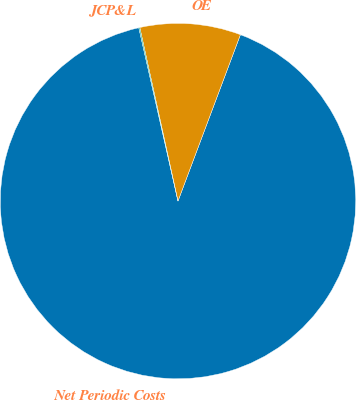<chart> <loc_0><loc_0><loc_500><loc_500><pie_chart><fcel>Net Periodic Costs<fcel>OE<fcel>JCP&L<nl><fcel>90.75%<fcel>9.16%<fcel>0.09%<nl></chart> 